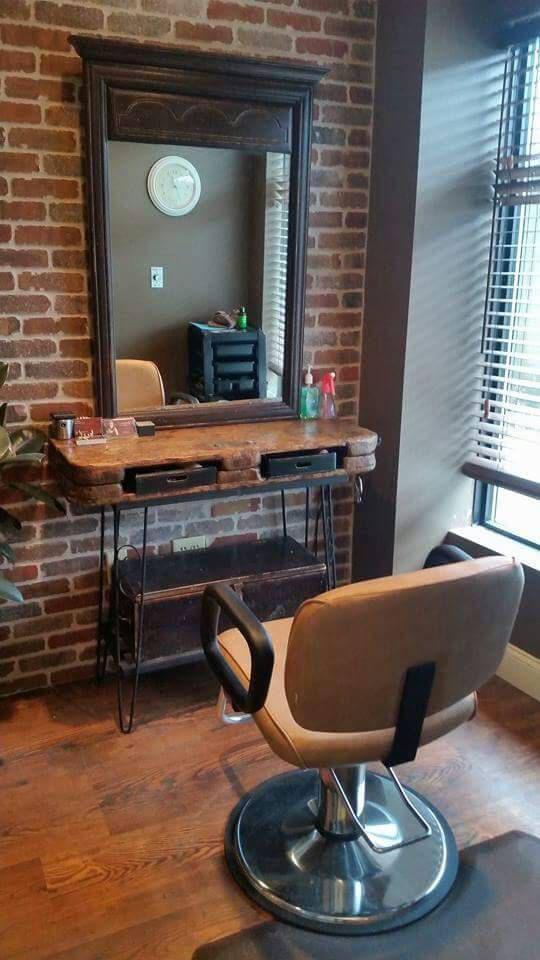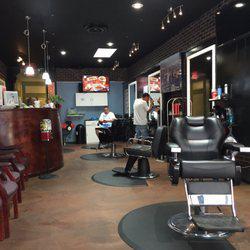The first image is the image on the left, the second image is the image on the right. Examine the images to the left and right. Is the description "The decor in one image features black surfaces predominantly." accurate? Answer yes or no. Yes. 